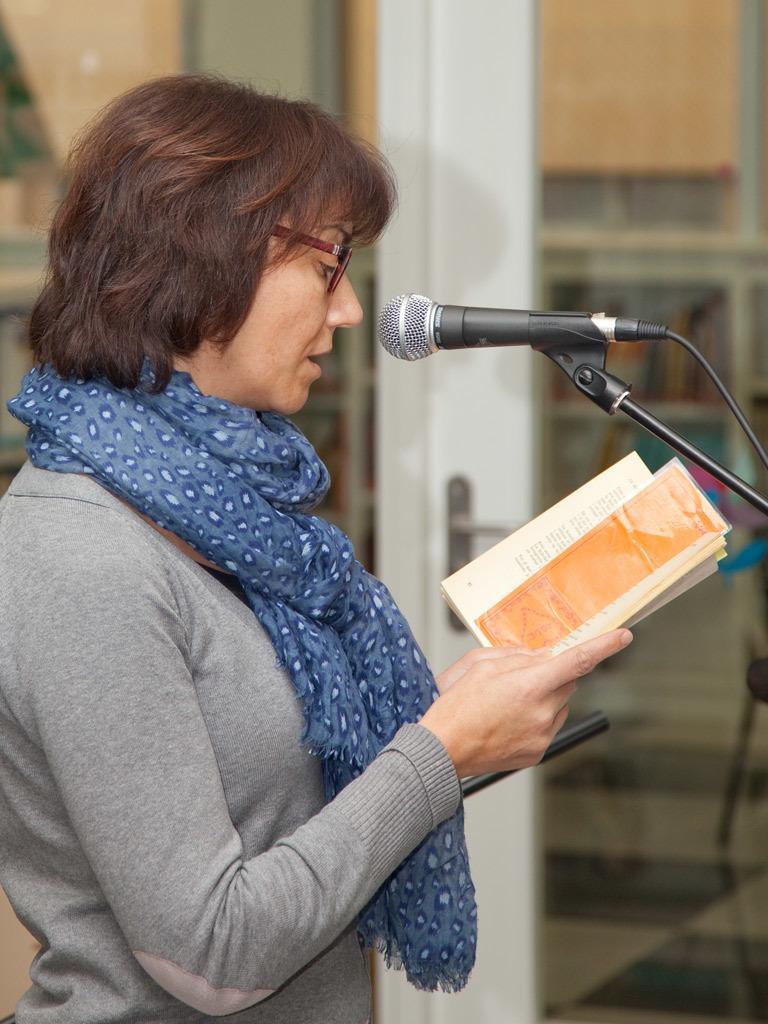Can you describe this image briefly? Here we can see a woman standing by holding a book in her hand at the mike. In the background there is a glass and we can see some objects over here. 